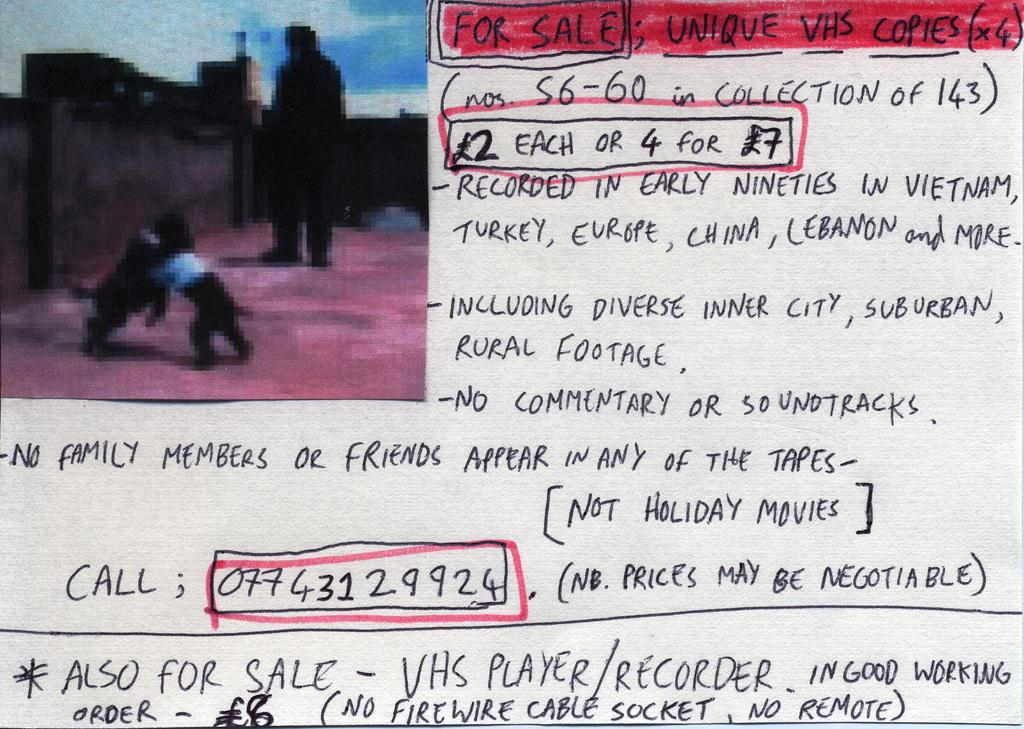What is present in the image that contains pictures and information? There is a poster in the image that contains pictures and information. Can you describe the content of the poster? The poster contains pictures and information, but the specific content cannot be determined from the provided facts. How many horses are depicted on the poster? There is no information about horses on the poster, as it contains pictures and information about other subjects. 